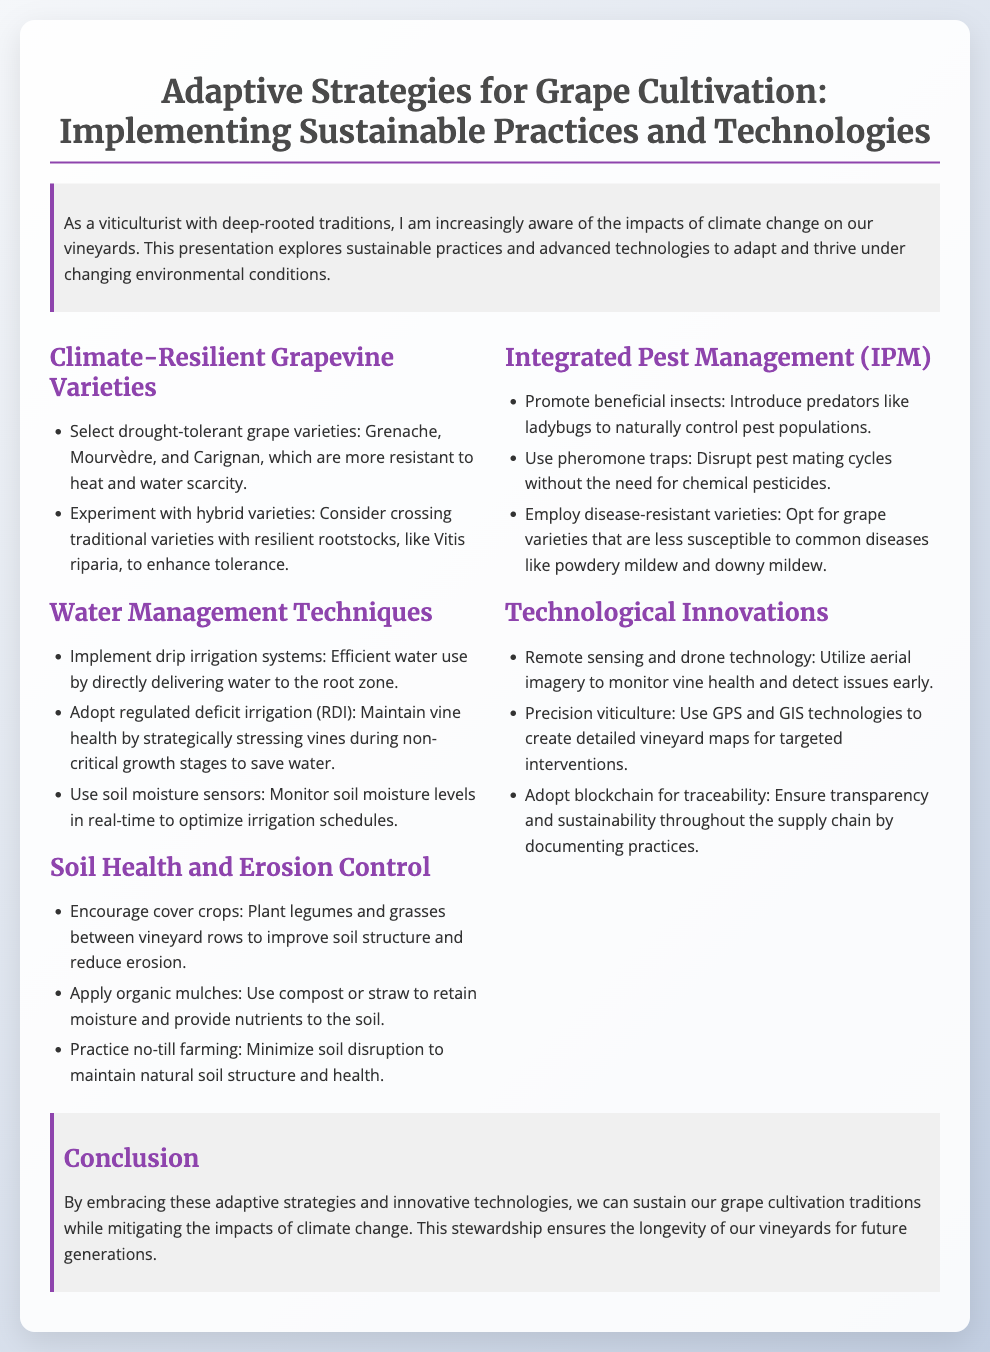What grape varieties are drought-tolerant? The document lists Grenache, Mourvèdre, and Carignan as drought-tolerant grape varieties.
Answer: Grenache, Mourvèdre, Carignan What irrigation technique is recommended for efficient water use? The presentation suggests implementing drip irrigation systems for efficient water use.
Answer: Drip irrigation What is one method for maintaining soil health? Encouraging cover crops is suggested as a method for improving soil structure and reducing erosion.
Answer: Cover crops Which innovative technology is used for monitoring vine health? Remote sensing and drone technology is utilized to monitor vine health and detect issues early.
Answer: Remote sensing and drone technology What does IPM stand for? IPM stands for Integrated Pest Management, as stated in the document.
Answer: Integrated Pest Management Which practice helps in retaining moisture in the soil? Applying organic mulches helps in retaining moisture in the soil.
Answer: Organic mulches What is emphasized in the conclusion? The conclusion emphasizes the importance of embracing adaptive strategies and innovative technologies in grape cultivation.
Answer: Adaptive strategies and innovative technologies What type of farming practice minimizes soil disruption? The document mentions practicing no-till farming as a way to minimize soil disruption.
Answer: No-till farming 